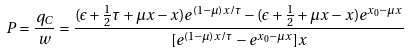Convert formula to latex. <formula><loc_0><loc_0><loc_500><loc_500>P = \frac { q _ { C } } { w } = \frac { ( \epsilon + \frac { 1 } { 2 } \tau + \mu x - x ) e ^ { ( 1 - \mu ) x / \tau } - ( \epsilon + \frac { 1 } { 2 } + \mu x - x ) e ^ { x _ { 0 } - \mu x } } { [ e ^ { ( 1 - \mu ) x / \tau } - e ^ { x _ { 0 } - \mu x } ] x }</formula> 